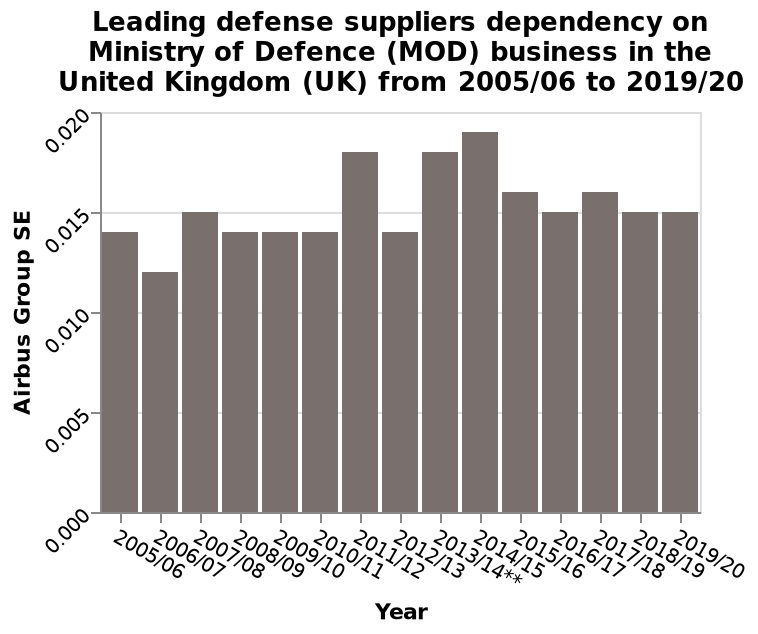<image>
What is being measured on the x-axis?  The x-axis is labeled as "Year" and represents the years from 2005/06 to 2019/20. When did Airbus Groups SE have its lowest year of business dependency?  Airbus Groups SE had its lowest year of business dependency in 2006/2007. Offer a thorough analysis of the image. Airbus Groups SE had its largest year of business dependecy in 2014/2015. Airbus Groups SE had its lowest year of business dependecy in 2006/2007Between 2008 and 2011 Airbus Group SE business deoeency on the MOD was linear. 